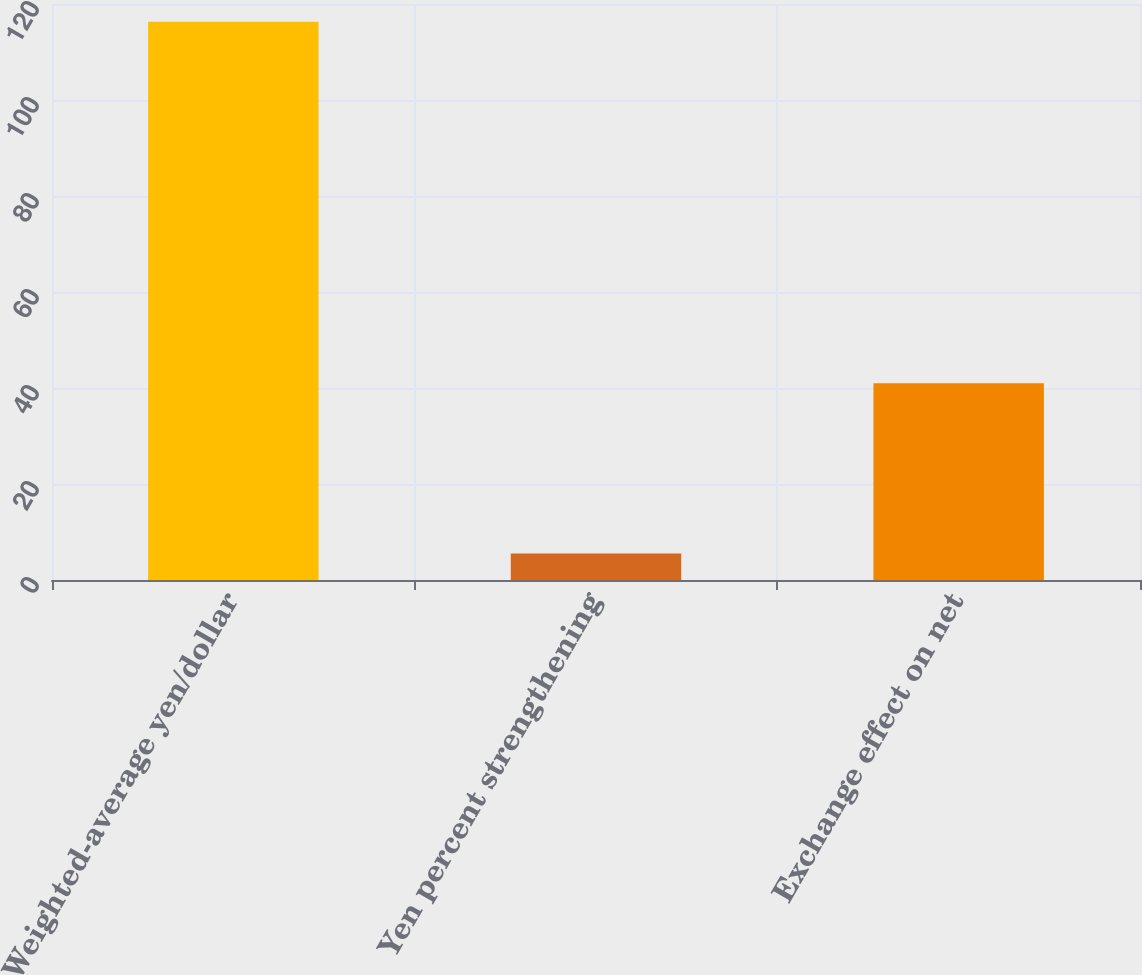Convert chart to OTSL. <chart><loc_0><loc_0><loc_500><loc_500><bar_chart><fcel>Weighted-average yen/dollar<fcel>Yen percent strengthening<fcel>Exchange effect on net<nl><fcel>116.31<fcel>5.5<fcel>41<nl></chart> 